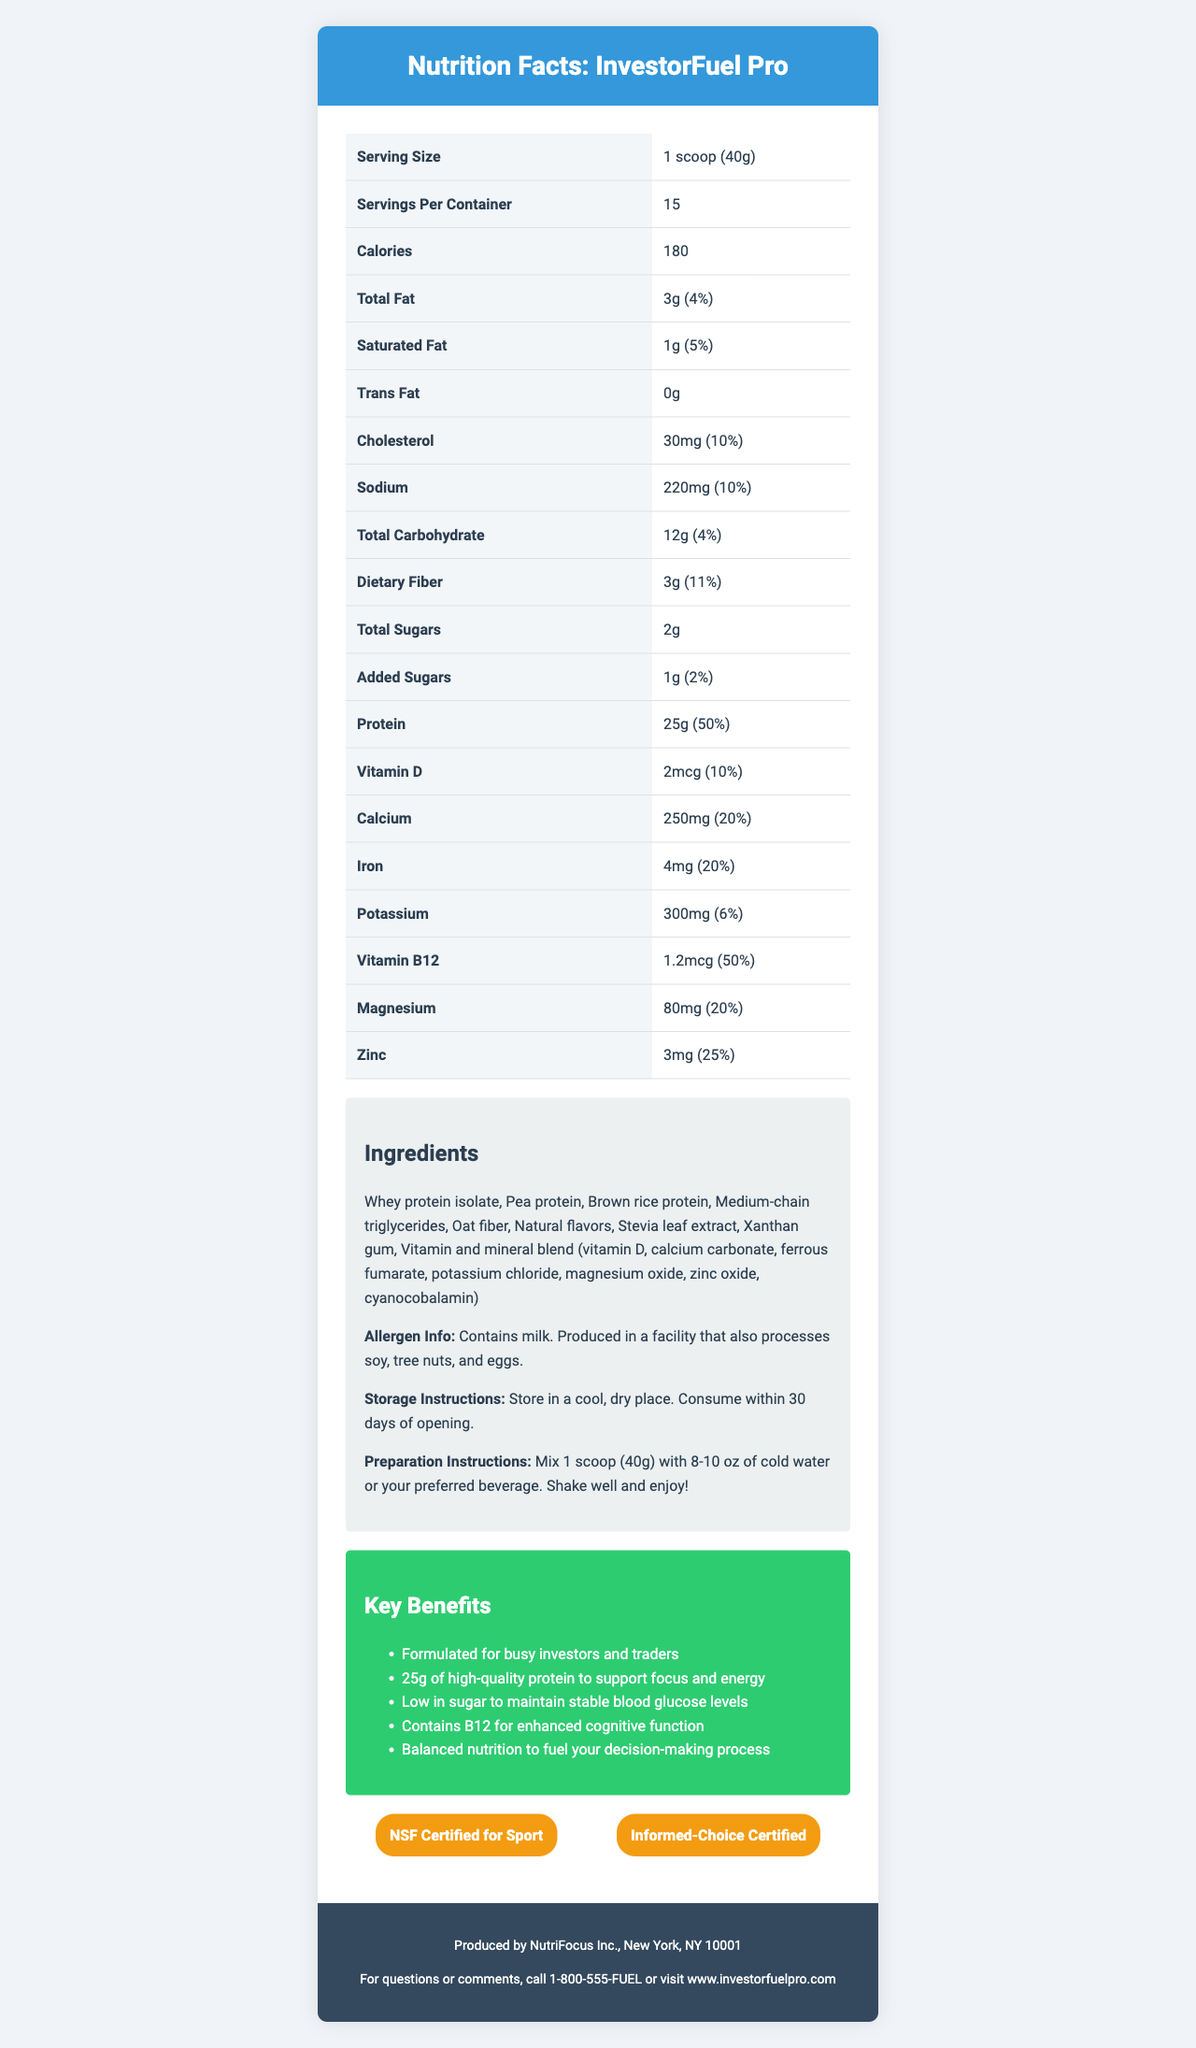what is the serving size for InvestorFuel Pro? The serving size is listed as 1 scoop (40g) under the serving size section in the document.
Answer: 1 scoop (40g) how many servings are there per container? The servings per container is specified as 15.
Answer: 15 what is the total fat content in one serving? The total fat content per serving is listed as 3g under the total fat section.
Answer: 3g what percentage of the daily value is the dietary fiber content? The dietary fiber content is 3g, which is 11% of the daily value.
Answer: 11% how much protein is provided in one serving? The protein content per serving is listed as 25g along with a daily value percentage of 50%.
Answer: 25g which vitamin is included to enhance cognitive function? A. Vitamin D B. Vitamin B12 C. Vitamin C D. Vitamin A The marketing claims section lists vitamin B12 for enhanced cognitive function.
Answer: B what is the caloric content of one serving? The caloric content for one serving is listed as 180 calories.
Answer: 180 calories what are the main protein sources in InvestorFuel Pro? The ingredients section lists the main protein sources as Whey protein isolate, Pea protein, and Brown rice protein.
Answer: Whey protein isolate, Pea protein, Brown rice protein which certifications does InvestorFuel Pro have? A. USDA Organic B. NSF Certified for Sport C. Non-GMO D. Informed-Choice Certified The certifications section lists NSF Certified for Sport and Informed-Choice Certified.
Answer: B, D does InvestorFuel Pro contain any allergens? Contains milk. Produced in a facility that also processes soy, tree nuts, and eggs according to the allergen info section.
Answer: Yes is there any trans fat in InvestorFuel Pro? The trans fat content is listed as 0g.
Answer: No how should InvestorFuel Pro be stored? The storage instructions specify to store in a cool, dry place and to consume within 30 days of opening.
Answer: Store in a cool, dry place. Consume within 30 days of opening. describe the main features and nutritional benefits of InvestorFuel Pro The document describes InvestorFuel Pro as a meal replacement shake for busy investors, highlighting its high protein content, cognitive support, low sugar, and balanced nutrition.
Answer: InvestorFuel Pro is a high-protein meal replacement shake designed for busy investors and traders. It provides 25g of protein per serving, supports focus and energy, and is low in sugar to maintain stable blood glucose levels. It also contains vitamin B12 for enhanced cognitive function and a variety of other vitamins and minerals for balanced nutrition. who is the manufacturer of InvestorFuel Pro? The manufacturer info section mentions that it is produced by NutriFocus Inc., New York, NY 10001.
Answer: NutriFocus Inc. how much calcium is in InvestorFuel Pro? The calcium content is listed as 250mg in one serving.
Answer: 250mg how many grams of added sugars are in a serving? The added sugars content per serving is listed as 1g.
Answer: 1g which nutrient provides the highest daily value percentage? The protein content provides the highest daily value at 50% as listed.
Answer: Protein (50%) what is the preparation instruction for InvestorFuel Pro? The preparation instructions specify to mix 1 scoop with 8-10 oz of cold water or preferred beverage, shake well, and enjoy.
Answer: Mix 1 scoop (40g) with 8-10 oz of cold water or your preferred beverage. Shake well and enjoy! can we determine the price of InvestorFuel Pro from the document? The document provides nutritional, ingredient, and usage details, but no information on the price.
Answer: Not enough information 